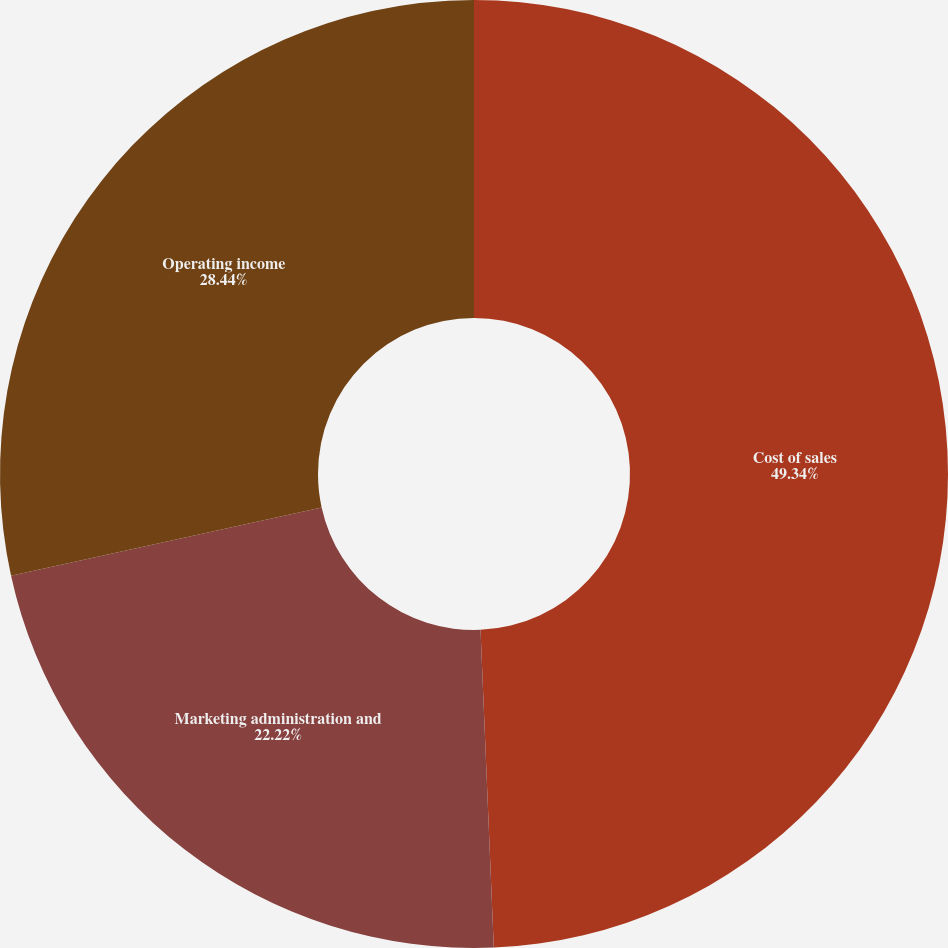Convert chart. <chart><loc_0><loc_0><loc_500><loc_500><pie_chart><fcel>Cost of sales<fcel>Marketing administration and<fcel>Operating income<nl><fcel>49.33%<fcel>22.22%<fcel>28.44%<nl></chart> 